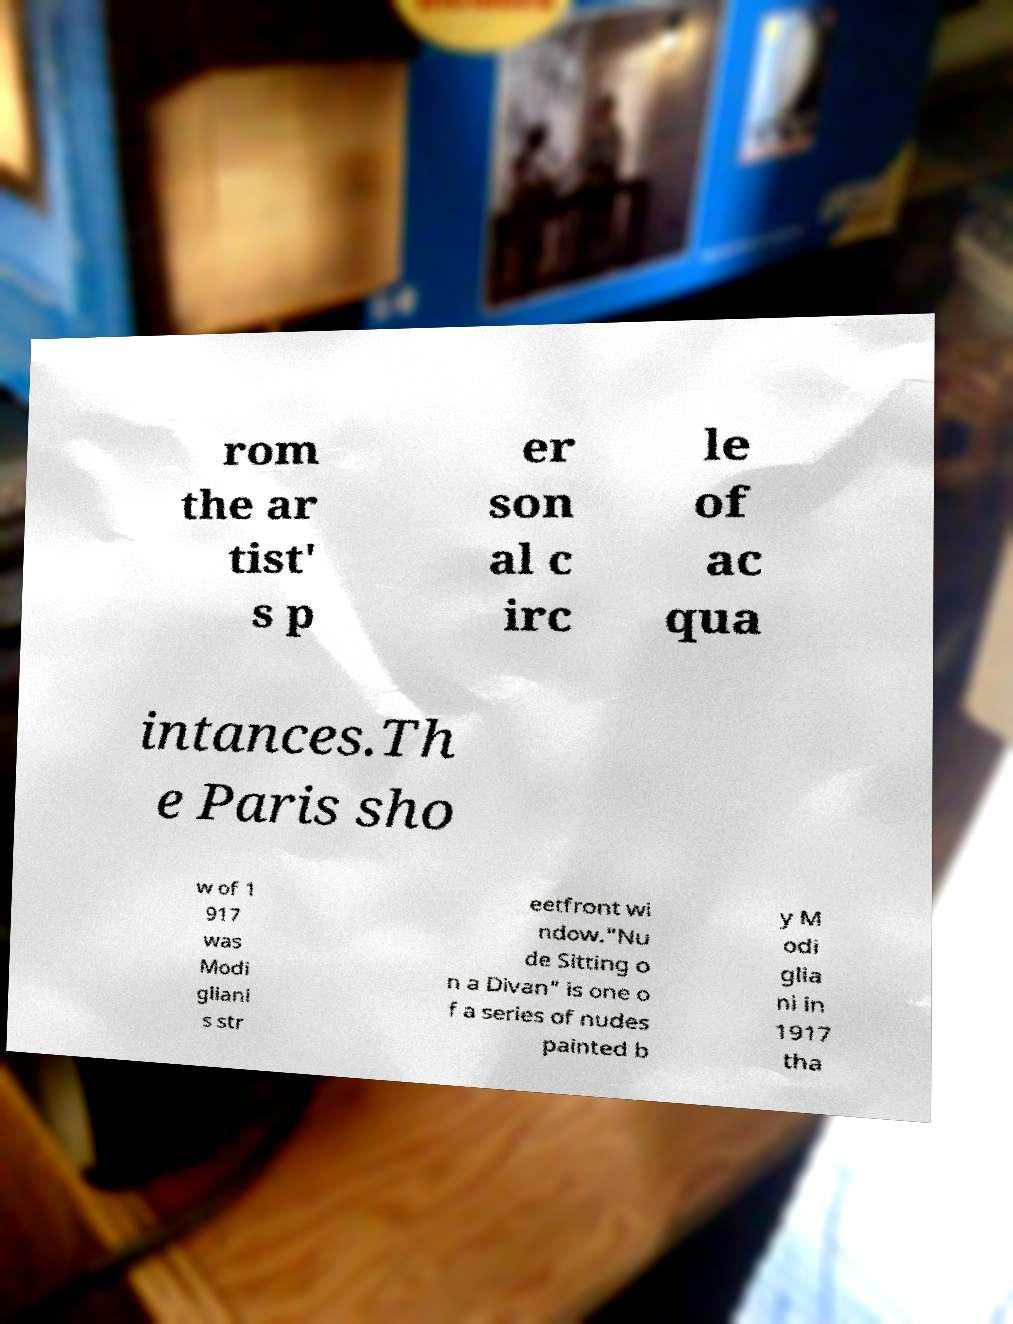There's text embedded in this image that I need extracted. Can you transcribe it verbatim? rom the ar tist' s p er son al c irc le of ac qua intances.Th e Paris sho w of 1 917 was Modi gliani s str eetfront wi ndow."Nu de Sitting o n a Divan" is one o f a series of nudes painted b y M odi glia ni in 1917 tha 